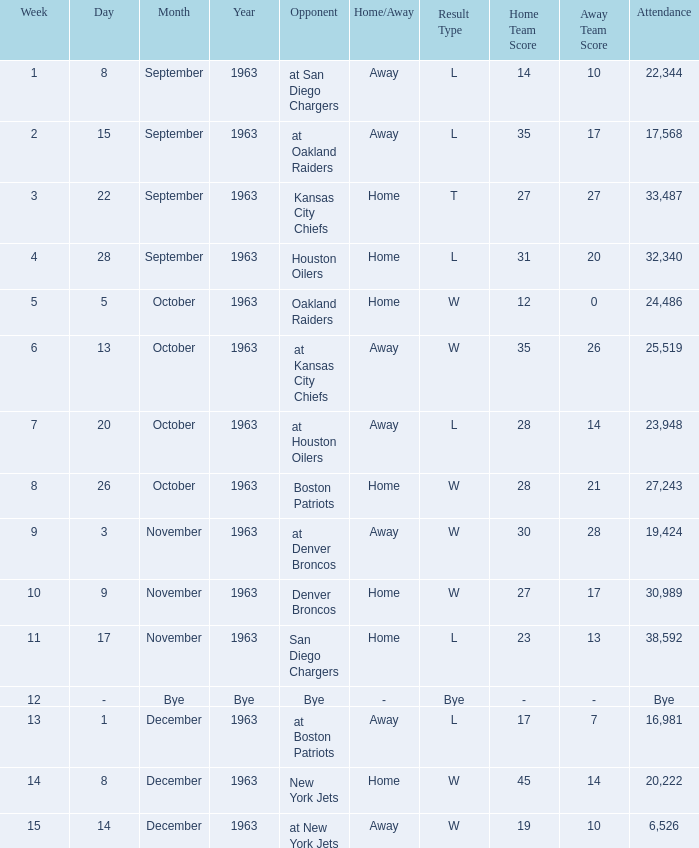Would you be able to parse every entry in this table? {'header': ['Week', 'Day', 'Month', 'Year', 'Opponent', 'Home/Away', 'Result Type', 'Home Team Score', 'Away Team Score', 'Attendance'], 'rows': [['1', '8', 'September', '1963', 'at San Diego Chargers', 'Away', 'L', '14', '10', '22,344'], ['2', '15', 'September', '1963', 'at Oakland Raiders', 'Away', 'L', '35', '17', '17,568'], ['3', '22', 'September', '1963', 'Kansas City Chiefs', 'Home', 'T', '27', '27', '33,487'], ['4', '28', 'September', '1963', 'Houston Oilers', 'Home', 'L', '31', '20', '32,340'], ['5', '5', 'October', '1963', 'Oakland Raiders', 'Home', 'W', '12', '0', '24,486'], ['6', '13', 'October', '1963', 'at Kansas City Chiefs', 'Away', 'W', '35', '26', '25,519'], ['7', '20', 'October', '1963', 'at Houston Oilers', 'Away', 'L', '28', '14', '23,948'], ['8', '26', 'October', '1963', 'Boston Patriots', 'Home', 'W', '28', '21', '27,243'], ['9', '3', 'November', '1963', 'at Denver Broncos', 'Away', 'W', '30', '28', '19,424'], ['10', '9', 'November', '1963', 'Denver Broncos', 'Home', 'W', '27', '17', '30,989'], ['11', '17', 'November', '1963', 'San Diego Chargers', 'Home', 'L', '23', '13', '38,592'], ['12', '-', 'Bye', 'Bye', 'Bye', '-', 'Bye', '-', '-', 'Bye'], ['13', '1', 'December', '1963', 'at Boston Patriots', 'Away', 'L', '17', '7', '16,981'], ['14', '8', 'December', '1963', 'New York Jets', 'Home', 'W', '45', '14', '20,222'], ['15', '14', 'December', '1963', 'at New York Jets', 'Away', 'W', '19', '10', '6,526']]} Which Opponent has a Date of november 17, 1963? San Diego Chargers. 